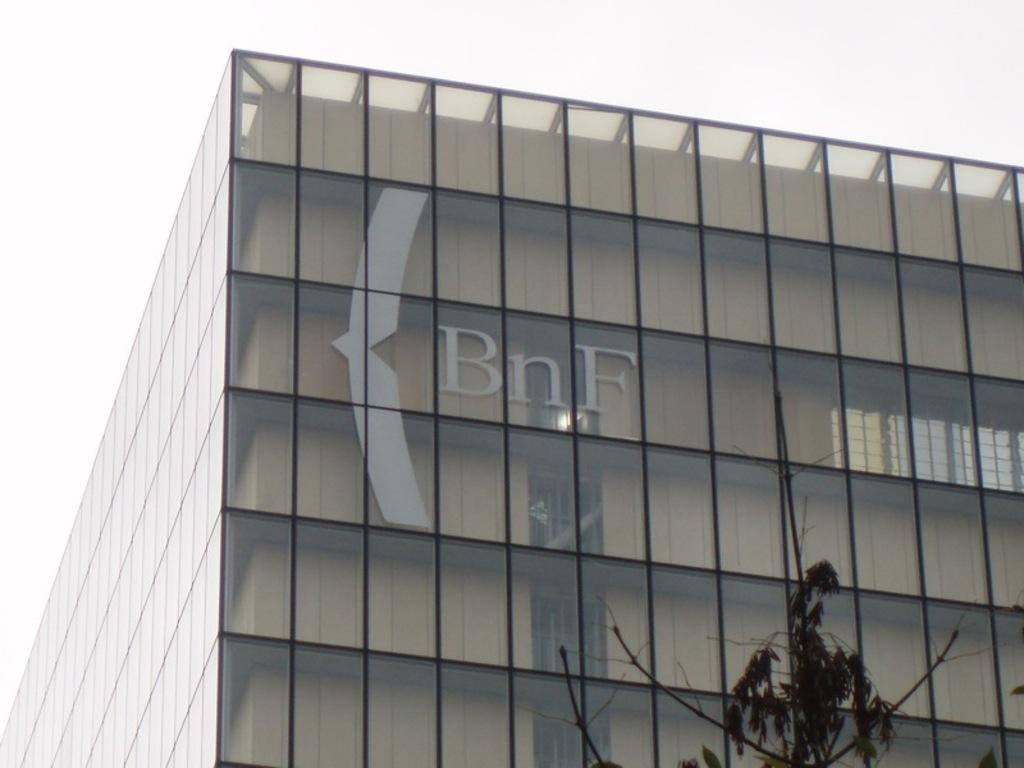Could you give a brief overview of what you see in this image? In the center of the image there is a building. At the bottom we can see a tree. In the background there is sky. 